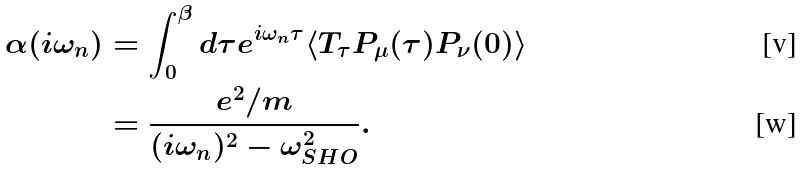<formula> <loc_0><loc_0><loc_500><loc_500>\alpha ( i \omega _ { n } ) & = \int _ { 0 } ^ { \beta } d \tau e ^ { i \omega _ { n } \tau } \langle T _ { \tau } P _ { \mu } ( \tau ) P _ { \nu } ( 0 ) \rangle \\ & = \frac { e ^ { 2 } / m } { ( i \omega _ { n } ) ^ { 2 } - \omega _ { S H O } ^ { 2 } } .</formula> 